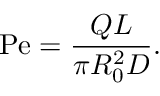Convert formula to latex. <formula><loc_0><loc_0><loc_500><loc_500>P e = \frac { Q L } { \pi R _ { 0 } ^ { 2 } D } .</formula> 